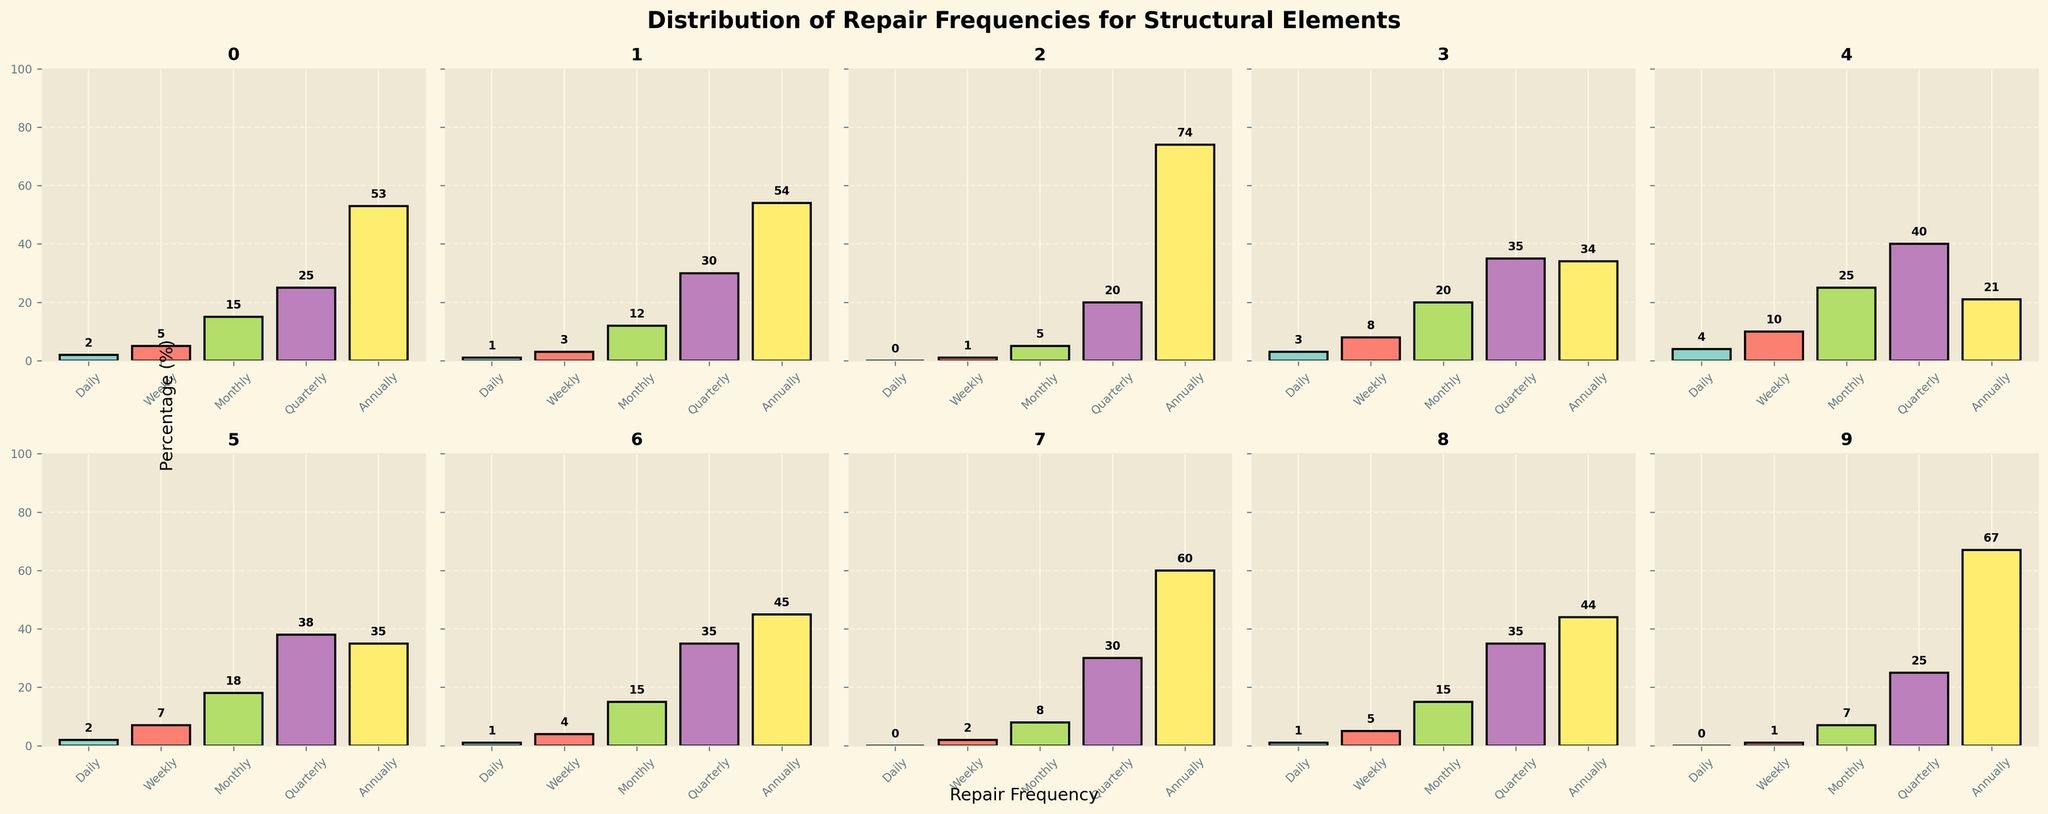Which structural element requires the most annual repairs? Looking at the tallest bar in the "Annually" category across all subplots, Beams have the highest annual repair frequency at 67%.
Answer: Beams Which structural element has the highest daily repair frequency? By comparing the heights of the bars in the "Daily" category across all subplots, Doors have the highest daily repair frequency at 4%.
Answer: Doors Which two structural elements have the exact same quarterly repair frequency? Observing the "Quarterly" bar heights across the subplots, Windows and Porches both have a quarterly repair frequency of 35%.
Answer: Windows and Porches What is the average annual repair frequency for Walls and Flooring? Summing the annual repair frequencies for Walls (54%) and Flooring (35%), then dividing by 2 gives the average: (54 + 35)/2 = 44.5.
Answer: 44.5 Which structural element has the least total repair frequency across all categories? Adding the repair frequencies across all categories for each structural element and comparing the totals, Foundation has the lowest total: 0+1+5+20+74=100.
Answer: Foundation What is the difference in quarterly repair frequency between Beams and Chimneys? Subtracting the quarterly repair frequency of Chimneys (30%) from that of Beams (25%) results in: 25 - 30 = -5.
Answer: -5 Does the porches bar for weekly repairs have a higher or lower value than the stairs bar for weekly repairs? Comparing the "Weekly" bars, Porches have a value of 4%, whereas Stairs have a value of 5%. Therefore, Porches are lower.
Answer: Lower Which has a higher monthly repair frequency, Windows or Doors? Comparing the heights of the "Monthly" bars, Windows have a value of 20%, while Doors have a value of 25%. Thus, Doors are higher.
Answer: Doors How much higher is the annual repair frequency for Chimneys compared to the foundation? Subtracting the annual repair frequency of Foundation (74%) from that of Chimneys (60%) results in: 74 - 60 = 14.
Answer: 14 What is the median value for Porches' repair frequencies? The sorted values for Porches are: 1 (Daily), 4 (Weekly), 15 (Monthly), 35 (Quarterly), 45 (Annually). The median value is the middle value, which is 15.
Answer: 15 